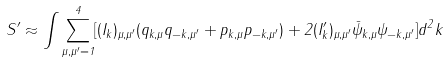<formula> <loc_0><loc_0><loc_500><loc_500>S ^ { \prime } \approx \int \sum _ { \mu , \mu ^ { \prime } = 1 } ^ { 4 } [ ( { I } _ { k } ) _ { \mu , \mu ^ { \prime } } ( q _ { k , \mu } q _ { - k , \mu ^ { \prime } } + p _ { k , \mu } p _ { - k , \mu ^ { \prime } } ) + 2 ( { I } _ { k } ^ { \prime } ) _ { \mu , \mu ^ { \prime } } { \bar { \psi } } _ { k , \mu } \psi _ { - k , \mu ^ { \prime } } ] d ^ { 2 } k</formula> 